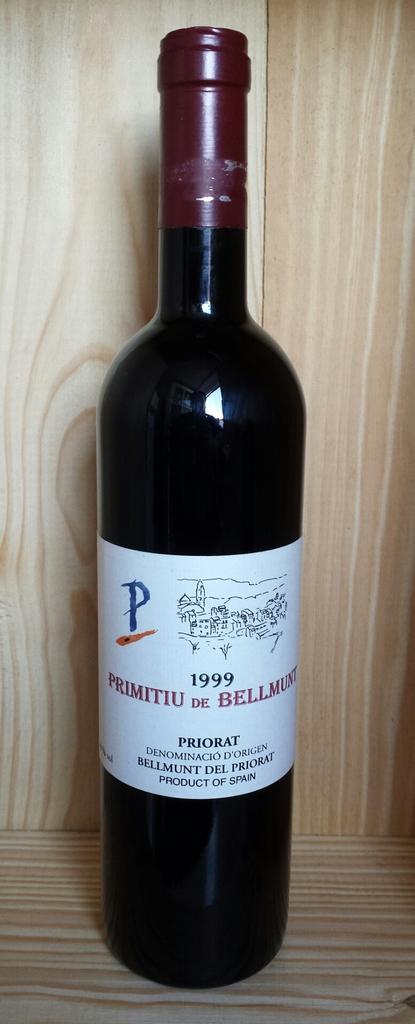What is the name of this wine in red?
Offer a terse response. Primitiu de bellmunt. 